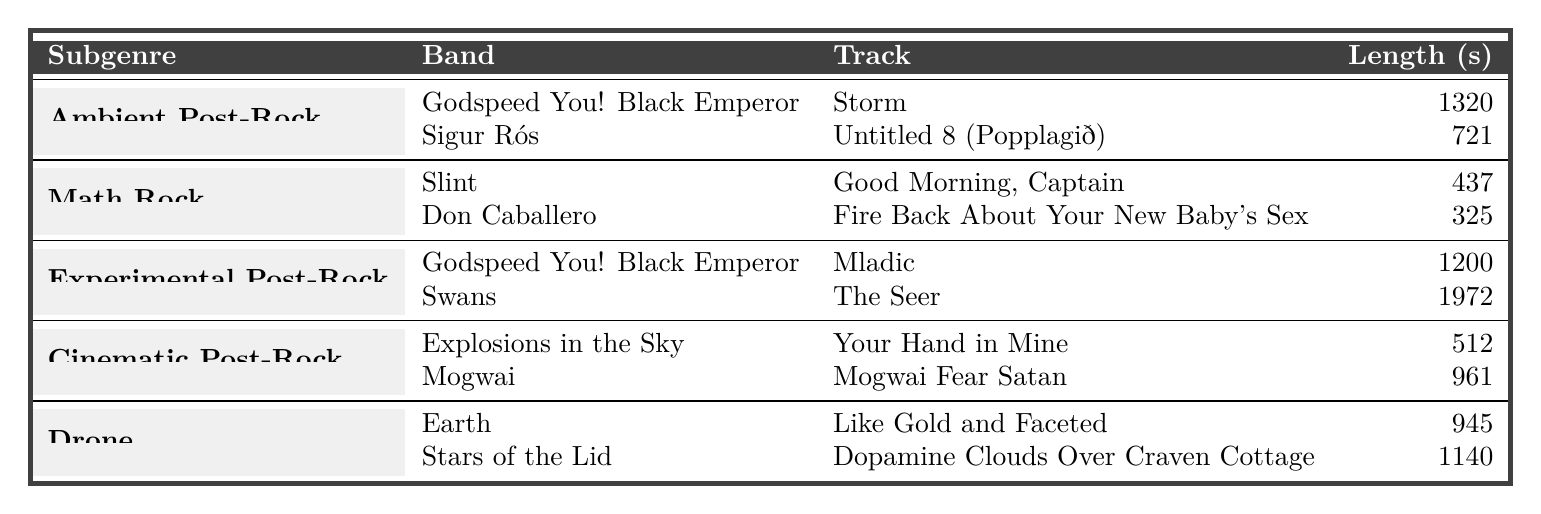What is the longest track in the table? The longest track can be found by comparing the lengths of the tracks listed in the "Length (s)" column. Swans' "The Seer" has the highest length at 1972 seconds.
Answer: 1972 seconds How many tracks are listed under the subgenre 'Ambient Post-Rock'? The table shows 2 tracks listed under 'Ambient Post-Rock', which are "Storm" by Godspeed You! Black Emperor and "Untitled 8 (Popplagið)" by Sigur Rós.
Answer: 2 tracks What is the total length of all tracks under the 'Math Rock' subgenre? To find the total length, we sum the lengths of the tracks under 'Math Rock': 437 (Slint) + 325 (Don Caballero) = 762 seconds.
Answer: 762 seconds Is "Mladic" the longest track in the 'Experimental Post-Rock' subgenre? "Mladic" is listed as 1200 seconds long, while "The Seer" by Swans is longer at 1972 seconds, making "Mladic" not the longest in its subgenre.
Answer: No What is the average track length of all tracks in the table? To find the average, we first sum all the lengths (1320 + 721 + 437 + 325 + 1200 + 1972 + 512 + 961 + 945 + 1140 = 7342) and divide by the number of tracks (10). This gives 7342 / 10 = 734.2 seconds.
Answer: 734.2 seconds Which subgenre has the shortest average track length? We calculate the average lengths for each subgenre: Ambient Post-Rock (1020.5), Math Rock (381), Experimental Post-Rock (1110), Cinematic Post-Rock (736.5), and Drone (1042.5). Math Rock has the shortest average at 381 seconds.
Answer: Math Rock How many bands listed have tracks over 900 seconds? From the table, the bands with tracks over 900 seconds are Godspeed You! Black Emperor (1320, 1200), Swans (1972), Stars of the Lid (1140), and Mogwai (961). So, there are 4 bands.
Answer: 4 bands Does Sigur Rós have a shorter track than Slint? "Untitled 8 (Popplagið)" by Sigur Rós is 721 seconds, while Slint's "Good Morning, Captain" is 437 seconds long. Since 721 > 437, Sigur Rós does not have a shorter track.
Answer: No What is the difference in track lengths between the longest and shortest tracks in the table? The longest track is 1972 seconds ("The Seer") and the shortest track is 325 seconds ("Fire Back About Your New Baby's Sex"). The difference is 1972 - 325 = 1647 seconds.
Answer: 1647 seconds 